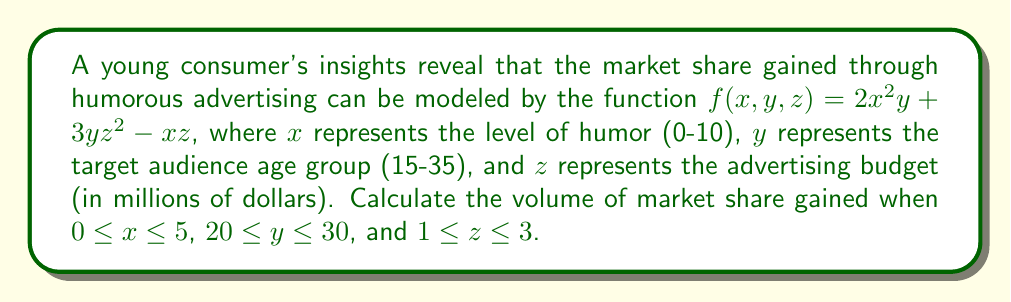Teach me how to tackle this problem. To solve this problem, we need to compute a triple integral over the given region. The volume of market share gained is represented by the integral of the function $f(x,y,z)$ over the specified bounds.

Step 1: Set up the triple integral
$$V = \iiint_R f(x,y,z) \, dV = \int_1^3 \int_{20}^{30} \int_0^5 (2x^2y + 3yz^2 - xz) \, dx \, dy \, dz$$

Step 2: Integrate with respect to x
$$\int_0^5 (2x^2y + 3yz^2 - xz) \, dx = \left[\frac{2}{3}x^3y + 3yz^2x - \frac{1}{2}xz^2\right]_0^5$$
$$= \left(\frac{250}{3}y + 15yz^2 - \frac{25}{2}z^2\right) - 0 = \frac{250}{3}y + 15yz^2 - \frac{25}{2}z^2$$

Step 3: Integrate with respect to y
$$\int_{20}^{30} \left(\frac{250}{3}y + 15yz^2 - \frac{25}{2}z^2\right) \, dy$$
$$= \left[\frac{125}{3}y^2 + \frac{15}{2}y^2z^2 - \frac{25}{2}yz^2\right]_{20}^{30}$$
$$= \left(\frac{112500}{3} + 6750z^2 - 375z^2\right) - \left(50000 + 3000z^2 - 250z^2\right)$$
$$= \frac{12500}{3} + 4000z^2 - 125z^2 = \frac{12500}{3} + 3875z^2$$

Step 4: Integrate with respect to z
$$\int_1^3 \left(\frac{12500}{3} + 3875z^2\right) \, dz$$
$$= \left[\frac{12500}{3}z + \frac{3875}{3}z^3\right]_1^3$$
$$= \left(12500 + 11625\right) - \left(\frac{12500}{3} + \frac{3875}{3}\right)$$
$$= 24125 - \frac{16375}{3} = \frac{56000}{3}$$

Therefore, the volume of market share gained is $\frac{56000}{3}$ units.
Answer: $\frac{56000}{3}$ units of market share 